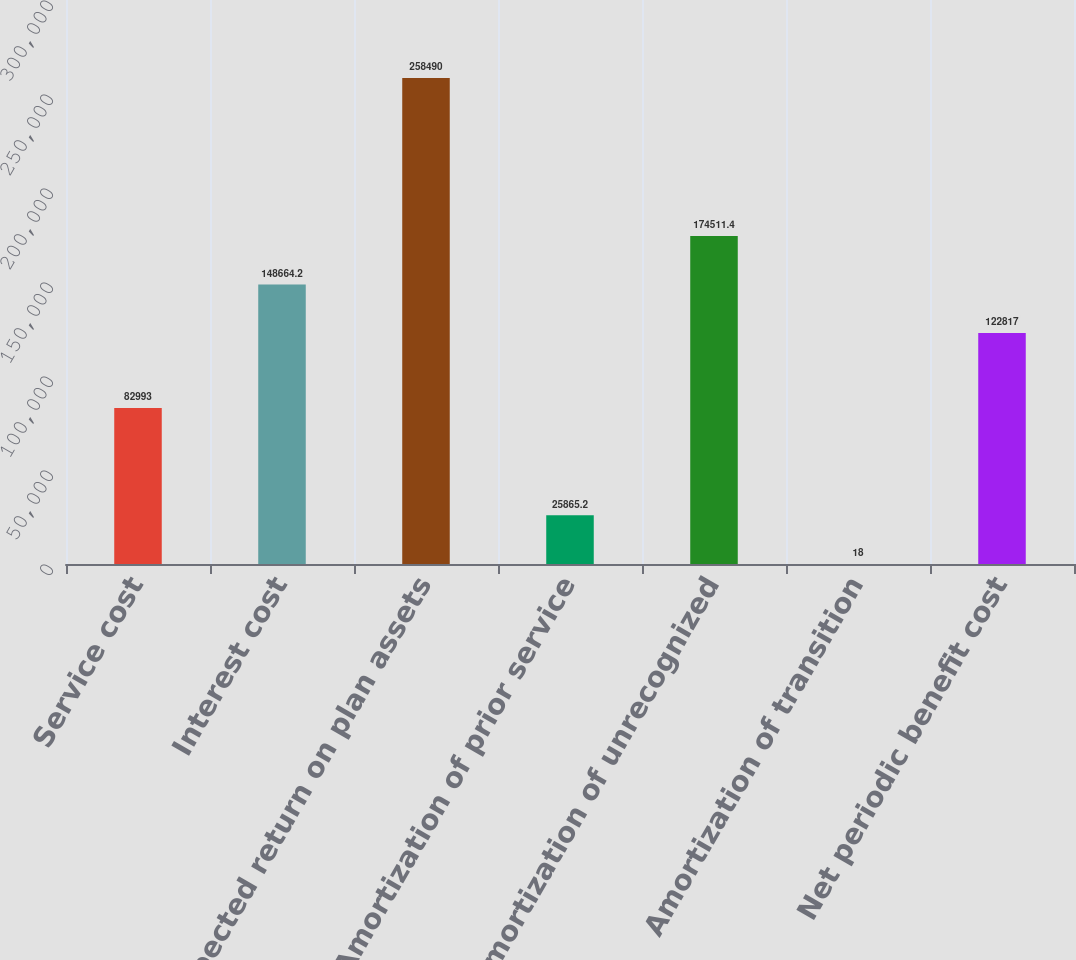Convert chart. <chart><loc_0><loc_0><loc_500><loc_500><bar_chart><fcel>Service cost<fcel>Interest cost<fcel>Expected return on plan assets<fcel>Amortization of prior service<fcel>Amortization of unrecognized<fcel>Amortization of transition<fcel>Net periodic benefit cost<nl><fcel>82993<fcel>148664<fcel>258490<fcel>25865.2<fcel>174511<fcel>18<fcel>122817<nl></chart> 